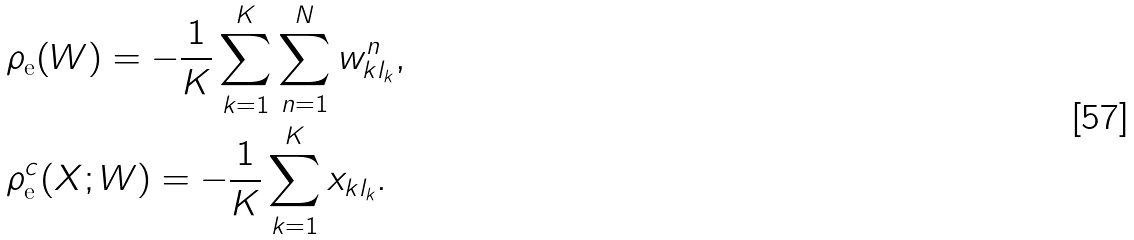<formula> <loc_0><loc_0><loc_500><loc_500>& \rho _ { \text {e} } ( W ) = - \frac { 1 } { K } \sum _ { k = 1 } ^ { K } \sum _ { n = 1 } ^ { N } w _ { k l _ { k } } ^ { n } , \\ & \rho _ { \text {e} } ^ { c } ( X ; W ) = - \frac { 1 } { K } \sum _ { k = 1 } ^ { K } x _ { k l _ { k } } .</formula> 